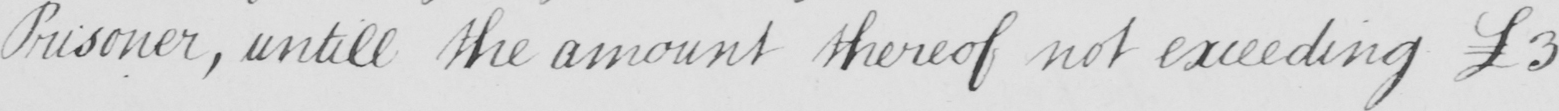Can you tell me what this handwritten text says? Prisoner , untill the amount thereof not exceeding £3 